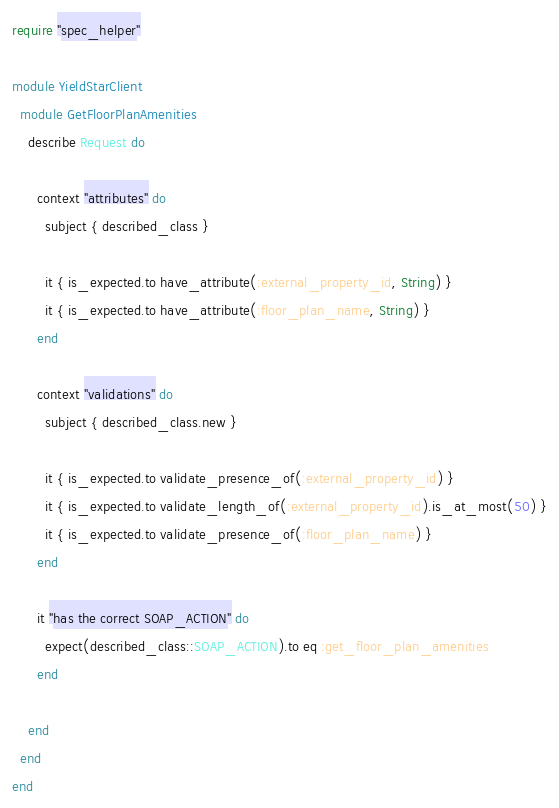Convert code to text. <code><loc_0><loc_0><loc_500><loc_500><_Ruby_>require "spec_helper"

module YieldStarClient
  module GetFloorPlanAmenities
    describe Request do

      context "attributes" do
        subject { described_class }

        it { is_expected.to have_attribute(:external_property_id, String) }
        it { is_expected.to have_attribute(:floor_plan_name, String) }
      end

      context "validations" do
        subject { described_class.new }

        it { is_expected.to validate_presence_of(:external_property_id) }
        it { is_expected.to validate_length_of(:external_property_id).is_at_most(50) }
        it { is_expected.to validate_presence_of(:floor_plan_name) }
      end

      it "has the correct SOAP_ACTION" do
        expect(described_class::SOAP_ACTION).to eq :get_floor_plan_amenities
      end

    end
  end
end
</code> 